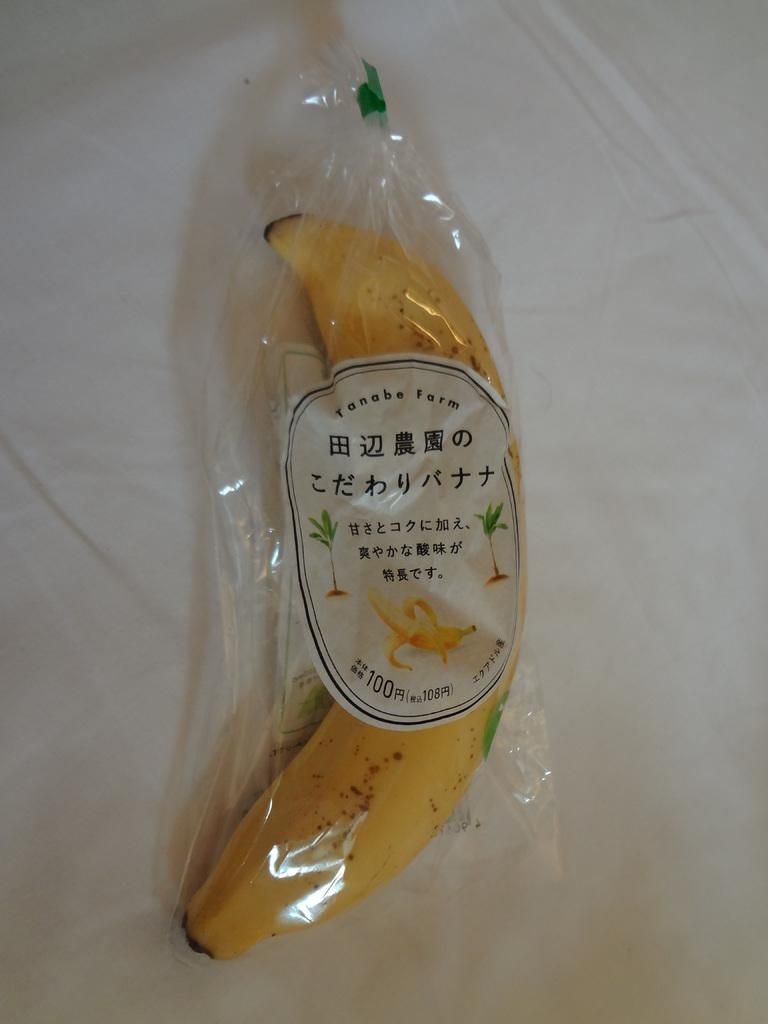<image>
Create a compact narrative representing the image presented. A banana wrapped in plastic that came from Tanabe Farm. 